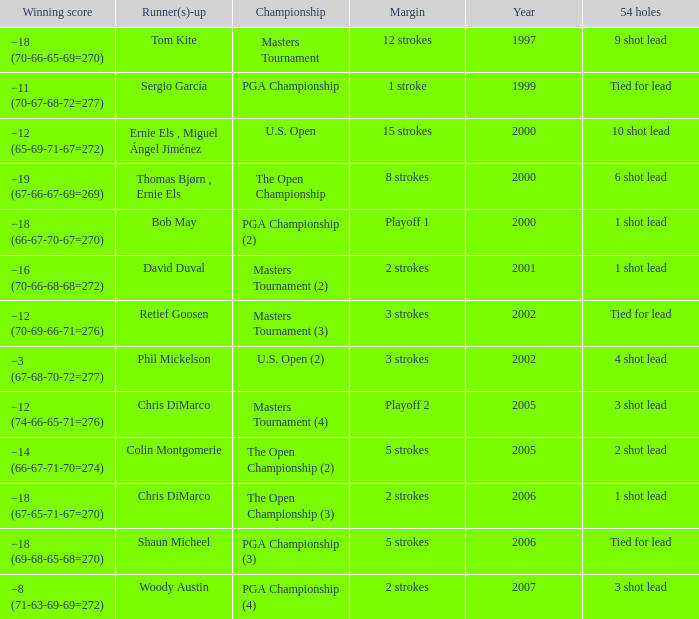 what's the margin where runner(s)-up is phil mickelson 3 strokes. Would you be able to parse every entry in this table? {'header': ['Winning score', 'Runner(s)-up', 'Championship', 'Margin', 'Year', '54 holes'], 'rows': [['−18 (70-66-65-69=270)', 'Tom Kite', 'Masters Tournament', '12 strokes', '1997', '9 shot lead'], ['−11 (70-67-68-72=277)', 'Sergio García', 'PGA Championship', '1 stroke', '1999', 'Tied for lead'], ['−12 (65-69-71-67=272)', 'Ernie Els , Miguel Ángel Jiménez', 'U.S. Open', '15 strokes', '2000', '10 shot lead'], ['−19 (67-66-67-69=269)', 'Thomas Bjørn , Ernie Els', 'The Open Championship', '8 strokes', '2000', '6 shot lead'], ['−18 (66-67-70-67=270)', 'Bob May', 'PGA Championship (2)', 'Playoff 1', '2000', '1 shot lead'], ['−16 (70-66-68-68=272)', 'David Duval', 'Masters Tournament (2)', '2 strokes', '2001', '1 shot lead'], ['−12 (70-69-66-71=276)', 'Retief Goosen', 'Masters Tournament (3)', '3 strokes', '2002', 'Tied for lead'], ['−3 (67-68-70-72=277)', 'Phil Mickelson', 'U.S. Open (2)', '3 strokes', '2002', '4 shot lead'], ['−12 (74-66-65-71=276)', 'Chris DiMarco', 'Masters Tournament (4)', 'Playoff 2', '2005', '3 shot lead'], ['−14 (66-67-71-70=274)', 'Colin Montgomerie', 'The Open Championship (2)', '5 strokes', '2005', '2 shot lead'], ['−18 (67-65-71-67=270)', 'Chris DiMarco', 'The Open Championship (3)', '2 strokes', '2006', '1 shot lead'], ['−18 (69-68-65-68=270)', 'Shaun Micheel', 'PGA Championship (3)', '5 strokes', '2006', 'Tied for lead'], ['−8 (71-63-69-69=272)', 'Woody Austin', 'PGA Championship (4)', '2 strokes', '2007', '3 shot lead']]} 